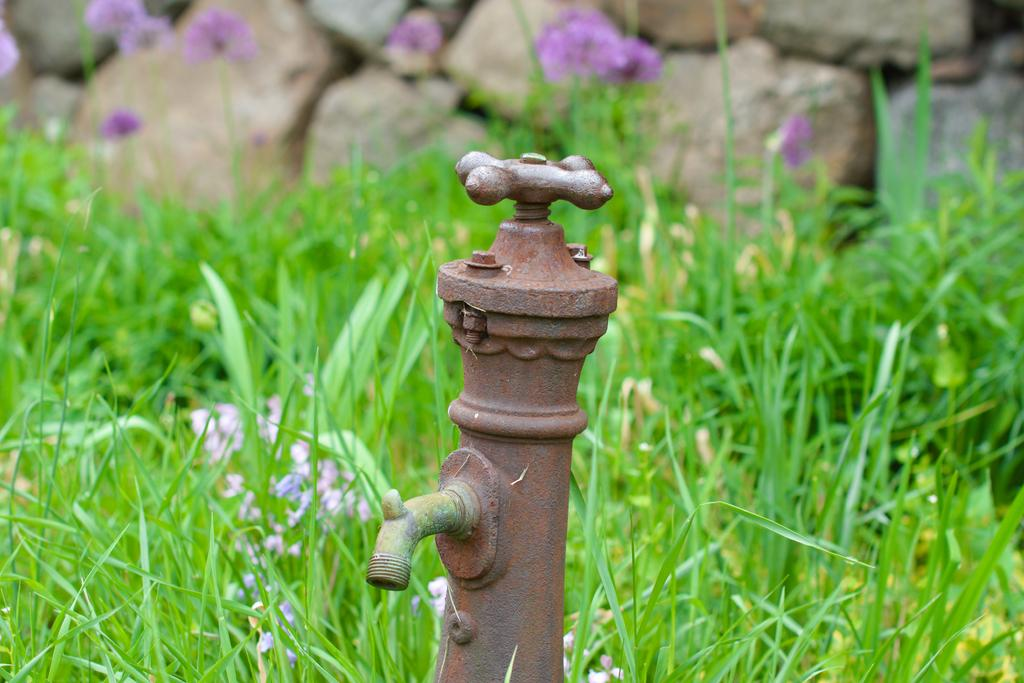What object is present in the image that can be used for dispensing water? There is a tap in the image that can be used for dispensing water. What type of natural environment is visible in the background of the image? The background of the image includes grass, flowers, and rocks. What type of support can be seen in the image? There is no specific support structure present in the image; it primarily features a tap and a natural background. What action is the dog performing in the image? There is no dog present in the image, so no action involving a dog can be observed. 